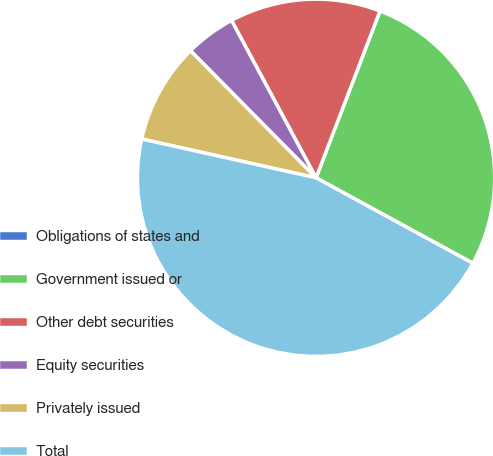<chart> <loc_0><loc_0><loc_500><loc_500><pie_chart><fcel>Obligations of states and<fcel>Government issued or<fcel>Other debt securities<fcel>Equity securities<fcel>Privately issued<fcel>Total<nl><fcel>0.01%<fcel>27.11%<fcel>13.67%<fcel>4.56%<fcel>9.11%<fcel>45.54%<nl></chart> 